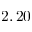Convert formula to latex. <formula><loc_0><loc_0><loc_500><loc_500>2 , 2 0</formula> 